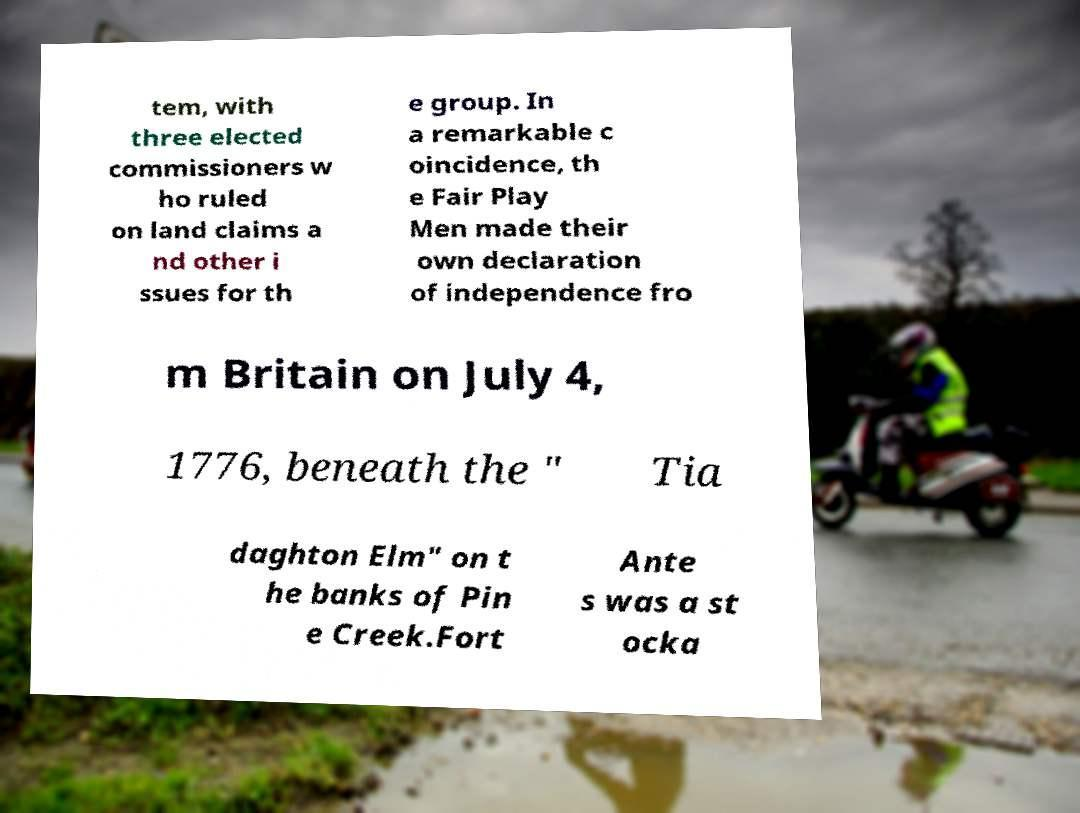Can you accurately transcribe the text from the provided image for me? tem, with three elected commissioners w ho ruled on land claims a nd other i ssues for th e group. In a remarkable c oincidence, th e Fair Play Men made their own declaration of independence fro m Britain on July 4, 1776, beneath the " Tia daghton Elm" on t he banks of Pin e Creek.Fort Ante s was a st ocka 